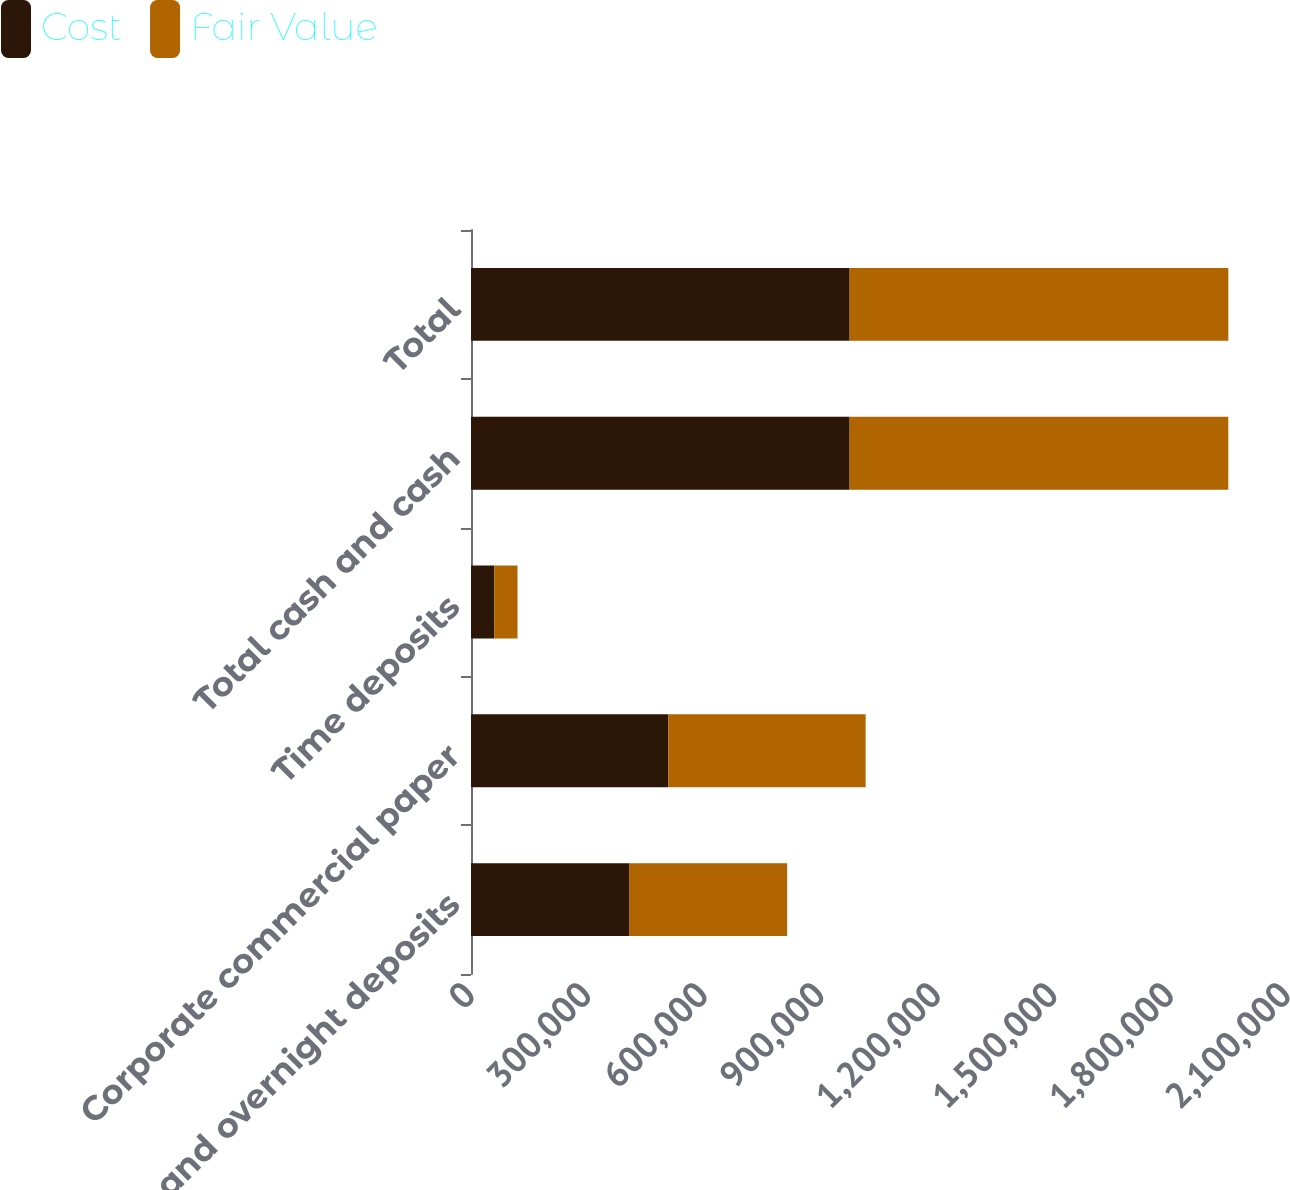<chart> <loc_0><loc_0><loc_500><loc_500><stacked_bar_chart><ecel><fcel>Cash and overnight deposits<fcel>Corporate commercial paper<fcel>Time deposits<fcel>Total cash and cash<fcel>Total<nl><fcel>Cost<fcel>406787<fcel>507777<fcel>59871<fcel>974435<fcel>974470<nl><fcel>Fair Value<fcel>406787<fcel>507889<fcel>59871<fcel>974547<fcel>974582<nl></chart> 